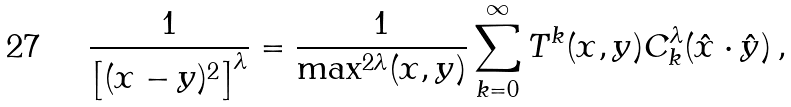<formula> <loc_0><loc_0><loc_500><loc_500>\frac { 1 } { \left [ ( x - y ) ^ { 2 } \right ] ^ { \lambda } } = \frac { 1 } { \max ^ { 2 \lambda } ( x , y ) } \sum _ { k = 0 } ^ { \infty } T ^ { k } ( x , y ) C ^ { \lambda } _ { k } ( \hat { x } \cdot \hat { y } ) \, ,</formula> 